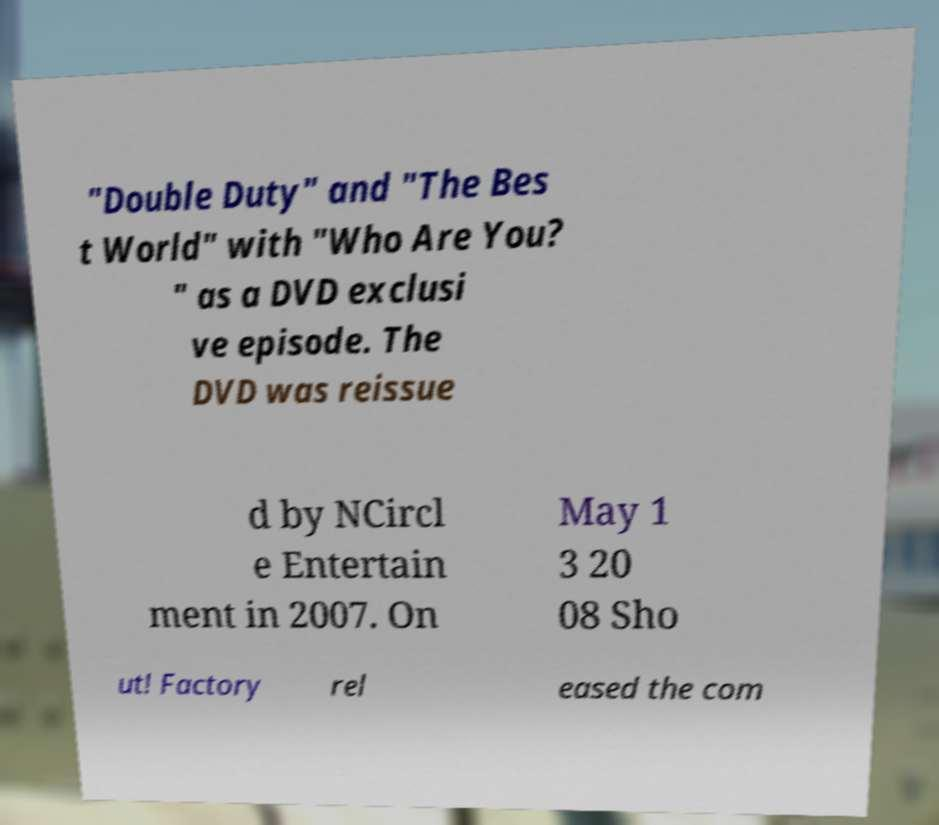For documentation purposes, I need the text within this image transcribed. Could you provide that? "Double Duty" and "The Bes t World" with "Who Are You? " as a DVD exclusi ve episode. The DVD was reissue d by NCircl e Entertain ment in 2007. On May 1 3 20 08 Sho ut! Factory rel eased the com 